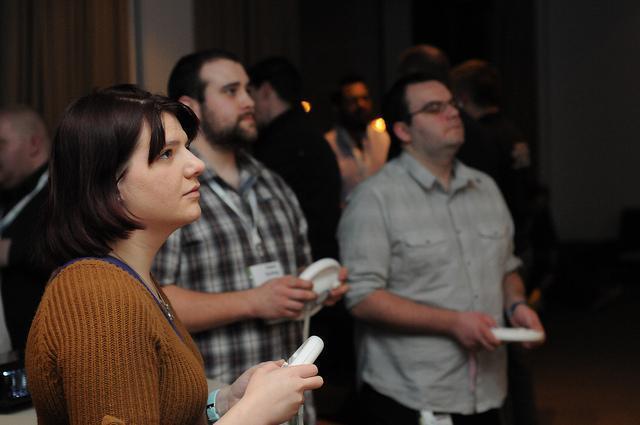How many people can be seen?
Give a very brief answer. 7. How many train cars are painted black?
Give a very brief answer. 0. 